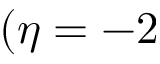Convert formula to latex. <formula><loc_0><loc_0><loc_500><loc_500>( \eta = - 2</formula> 